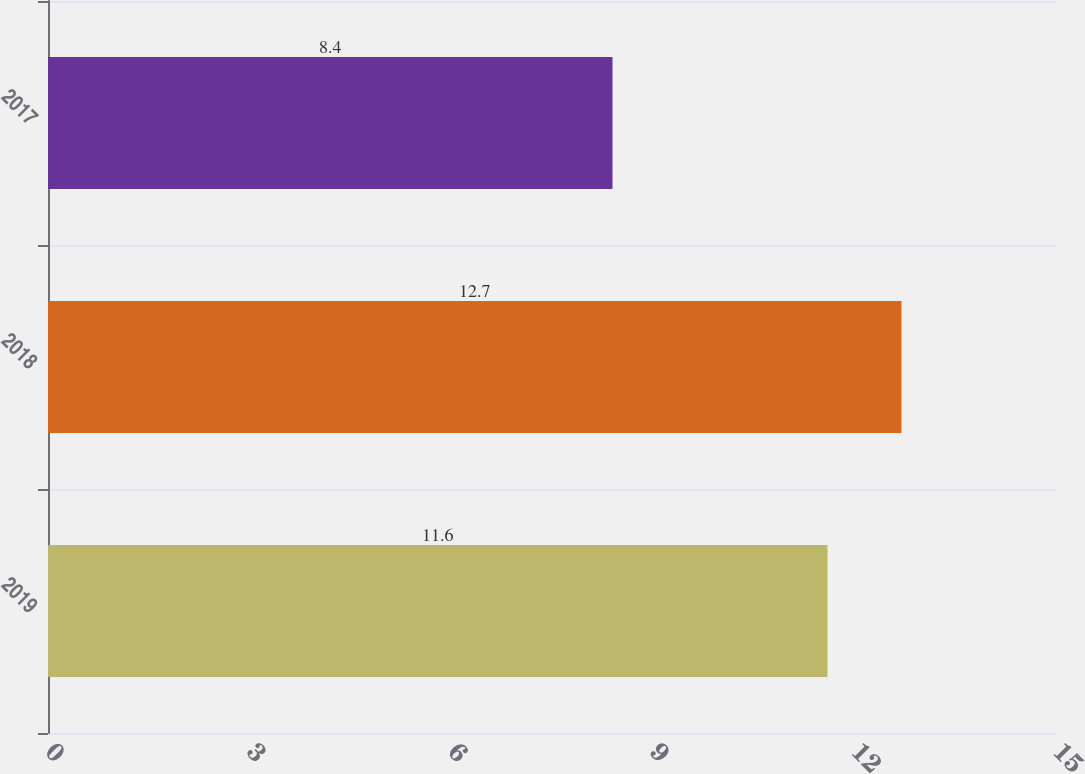<chart> <loc_0><loc_0><loc_500><loc_500><bar_chart><fcel>2019<fcel>2018<fcel>2017<nl><fcel>11.6<fcel>12.7<fcel>8.4<nl></chart> 